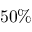Convert formula to latex. <formula><loc_0><loc_0><loc_500><loc_500>5 0 \%</formula> 